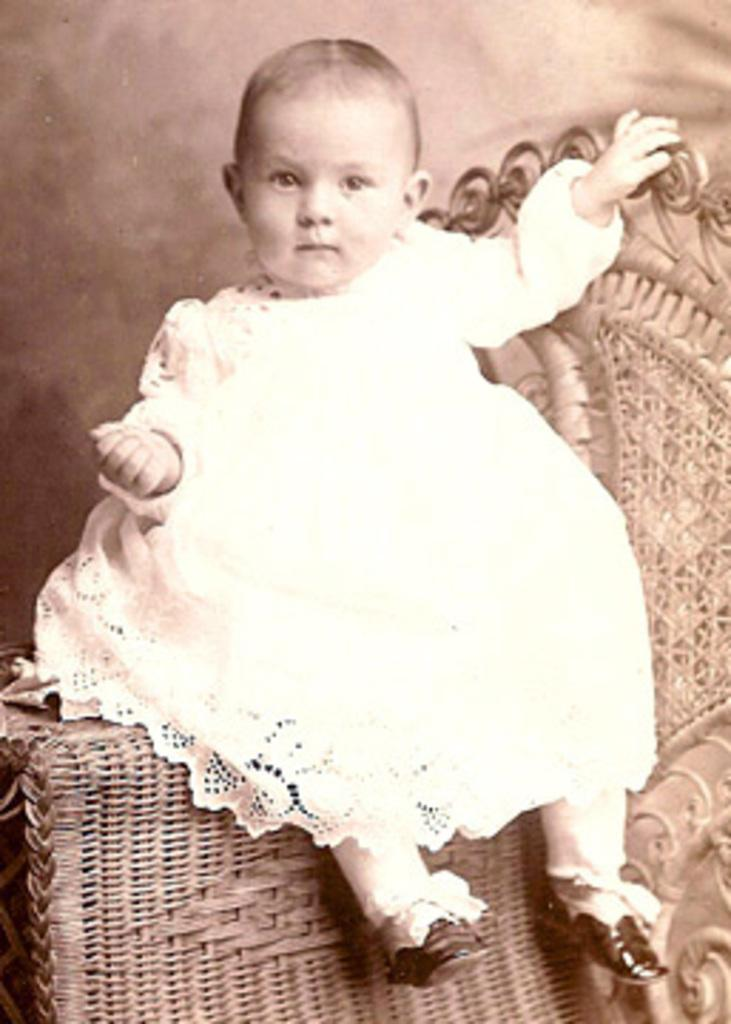What is the main subject of the image? The main subject of the image is a baby. What is the baby doing in the image? The baby is sitting on the handle of a chair. What type of ear is visible in the image? There is no ear visible in the image; it features a baby sitting on the handle of a chair. What kind of flowers can be seen in the background of the image? There is no background or flowers present in the image; it only shows a baby sitting on the handle of a chair. 